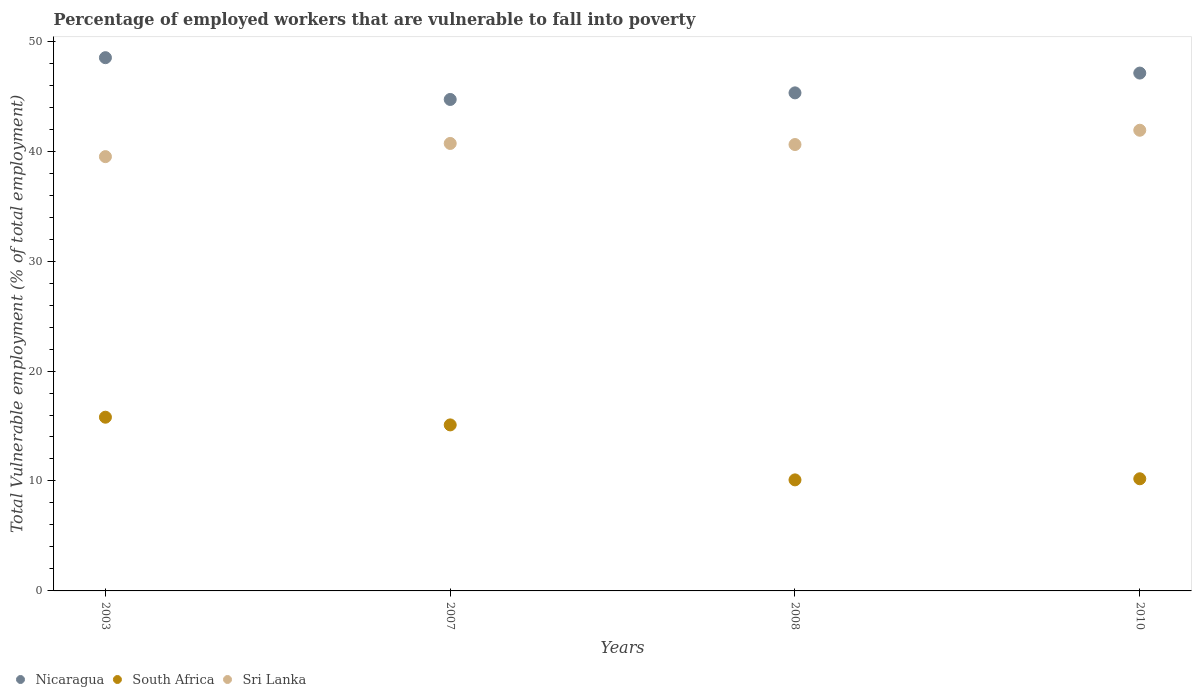How many different coloured dotlines are there?
Ensure brevity in your answer.  3. Is the number of dotlines equal to the number of legend labels?
Your answer should be compact. Yes. What is the percentage of employed workers who are vulnerable to fall into poverty in South Africa in 2007?
Your answer should be very brief. 15.1. Across all years, what is the maximum percentage of employed workers who are vulnerable to fall into poverty in South Africa?
Offer a terse response. 15.8. Across all years, what is the minimum percentage of employed workers who are vulnerable to fall into poverty in South Africa?
Your answer should be very brief. 10.1. What is the total percentage of employed workers who are vulnerable to fall into poverty in Nicaragua in the graph?
Make the answer very short. 185.6. What is the difference between the percentage of employed workers who are vulnerable to fall into poverty in Sri Lanka in 2003 and that in 2010?
Provide a short and direct response. -2.4. What is the difference between the percentage of employed workers who are vulnerable to fall into poverty in South Africa in 2008 and the percentage of employed workers who are vulnerable to fall into poverty in Sri Lanka in 2007?
Keep it short and to the point. -30.6. What is the average percentage of employed workers who are vulnerable to fall into poverty in South Africa per year?
Your answer should be compact. 12.8. In the year 2010, what is the difference between the percentage of employed workers who are vulnerable to fall into poverty in Sri Lanka and percentage of employed workers who are vulnerable to fall into poverty in Nicaragua?
Provide a short and direct response. -5.2. In how many years, is the percentage of employed workers who are vulnerable to fall into poverty in Sri Lanka greater than 4 %?
Offer a very short reply. 4. What is the ratio of the percentage of employed workers who are vulnerable to fall into poverty in Sri Lanka in 2003 to that in 2010?
Offer a very short reply. 0.94. What is the difference between the highest and the second highest percentage of employed workers who are vulnerable to fall into poverty in Nicaragua?
Provide a short and direct response. 1.4. What is the difference between the highest and the lowest percentage of employed workers who are vulnerable to fall into poverty in Nicaragua?
Give a very brief answer. 3.8. In how many years, is the percentage of employed workers who are vulnerable to fall into poverty in South Africa greater than the average percentage of employed workers who are vulnerable to fall into poverty in South Africa taken over all years?
Provide a short and direct response. 2. Is the percentage of employed workers who are vulnerable to fall into poverty in Nicaragua strictly less than the percentage of employed workers who are vulnerable to fall into poverty in Sri Lanka over the years?
Keep it short and to the point. No. How many dotlines are there?
Your answer should be very brief. 3. What is the difference between two consecutive major ticks on the Y-axis?
Keep it short and to the point. 10. Does the graph contain any zero values?
Provide a short and direct response. No. Does the graph contain grids?
Your answer should be compact. No. Where does the legend appear in the graph?
Provide a succinct answer. Bottom left. How many legend labels are there?
Make the answer very short. 3. What is the title of the graph?
Offer a terse response. Percentage of employed workers that are vulnerable to fall into poverty. Does "Middle East & North Africa (all income levels)" appear as one of the legend labels in the graph?
Keep it short and to the point. No. What is the label or title of the X-axis?
Give a very brief answer. Years. What is the label or title of the Y-axis?
Your response must be concise. Total Vulnerable employment (% of total employment). What is the Total Vulnerable employment (% of total employment) in Nicaragua in 2003?
Provide a succinct answer. 48.5. What is the Total Vulnerable employment (% of total employment) in South Africa in 2003?
Provide a succinct answer. 15.8. What is the Total Vulnerable employment (% of total employment) of Sri Lanka in 2003?
Make the answer very short. 39.5. What is the Total Vulnerable employment (% of total employment) of Nicaragua in 2007?
Your answer should be very brief. 44.7. What is the Total Vulnerable employment (% of total employment) of South Africa in 2007?
Ensure brevity in your answer.  15.1. What is the Total Vulnerable employment (% of total employment) of Sri Lanka in 2007?
Provide a short and direct response. 40.7. What is the Total Vulnerable employment (% of total employment) of Nicaragua in 2008?
Give a very brief answer. 45.3. What is the Total Vulnerable employment (% of total employment) in South Africa in 2008?
Provide a short and direct response. 10.1. What is the Total Vulnerable employment (% of total employment) of Sri Lanka in 2008?
Your answer should be compact. 40.6. What is the Total Vulnerable employment (% of total employment) in Nicaragua in 2010?
Your answer should be compact. 47.1. What is the Total Vulnerable employment (% of total employment) in South Africa in 2010?
Give a very brief answer. 10.2. What is the Total Vulnerable employment (% of total employment) of Sri Lanka in 2010?
Offer a terse response. 41.9. Across all years, what is the maximum Total Vulnerable employment (% of total employment) in Nicaragua?
Offer a very short reply. 48.5. Across all years, what is the maximum Total Vulnerable employment (% of total employment) of South Africa?
Your response must be concise. 15.8. Across all years, what is the maximum Total Vulnerable employment (% of total employment) in Sri Lanka?
Your answer should be very brief. 41.9. Across all years, what is the minimum Total Vulnerable employment (% of total employment) in Nicaragua?
Keep it short and to the point. 44.7. Across all years, what is the minimum Total Vulnerable employment (% of total employment) of South Africa?
Make the answer very short. 10.1. Across all years, what is the minimum Total Vulnerable employment (% of total employment) in Sri Lanka?
Provide a succinct answer. 39.5. What is the total Total Vulnerable employment (% of total employment) of Nicaragua in the graph?
Your answer should be very brief. 185.6. What is the total Total Vulnerable employment (% of total employment) in South Africa in the graph?
Give a very brief answer. 51.2. What is the total Total Vulnerable employment (% of total employment) of Sri Lanka in the graph?
Give a very brief answer. 162.7. What is the difference between the Total Vulnerable employment (% of total employment) of Nicaragua in 2003 and that in 2008?
Your answer should be compact. 3.2. What is the difference between the Total Vulnerable employment (% of total employment) of Sri Lanka in 2003 and that in 2008?
Keep it short and to the point. -1.1. What is the difference between the Total Vulnerable employment (% of total employment) in Nicaragua in 2003 and that in 2010?
Ensure brevity in your answer.  1.4. What is the difference between the Total Vulnerable employment (% of total employment) of South Africa in 2003 and that in 2010?
Provide a succinct answer. 5.6. What is the difference between the Total Vulnerable employment (% of total employment) of Sri Lanka in 2003 and that in 2010?
Offer a very short reply. -2.4. What is the difference between the Total Vulnerable employment (% of total employment) of Nicaragua in 2007 and that in 2008?
Offer a terse response. -0.6. What is the difference between the Total Vulnerable employment (% of total employment) of Nicaragua in 2007 and that in 2010?
Your response must be concise. -2.4. What is the difference between the Total Vulnerable employment (% of total employment) of South Africa in 2007 and that in 2010?
Provide a succinct answer. 4.9. What is the difference between the Total Vulnerable employment (% of total employment) in Nicaragua in 2008 and that in 2010?
Provide a succinct answer. -1.8. What is the difference between the Total Vulnerable employment (% of total employment) of South Africa in 2008 and that in 2010?
Your answer should be compact. -0.1. What is the difference between the Total Vulnerable employment (% of total employment) in Sri Lanka in 2008 and that in 2010?
Make the answer very short. -1.3. What is the difference between the Total Vulnerable employment (% of total employment) of Nicaragua in 2003 and the Total Vulnerable employment (% of total employment) of South Africa in 2007?
Provide a succinct answer. 33.4. What is the difference between the Total Vulnerable employment (% of total employment) of South Africa in 2003 and the Total Vulnerable employment (% of total employment) of Sri Lanka in 2007?
Your answer should be compact. -24.9. What is the difference between the Total Vulnerable employment (% of total employment) of Nicaragua in 2003 and the Total Vulnerable employment (% of total employment) of South Africa in 2008?
Keep it short and to the point. 38.4. What is the difference between the Total Vulnerable employment (% of total employment) in Nicaragua in 2003 and the Total Vulnerable employment (% of total employment) in Sri Lanka in 2008?
Ensure brevity in your answer.  7.9. What is the difference between the Total Vulnerable employment (% of total employment) of South Africa in 2003 and the Total Vulnerable employment (% of total employment) of Sri Lanka in 2008?
Your response must be concise. -24.8. What is the difference between the Total Vulnerable employment (% of total employment) in Nicaragua in 2003 and the Total Vulnerable employment (% of total employment) in South Africa in 2010?
Ensure brevity in your answer.  38.3. What is the difference between the Total Vulnerable employment (% of total employment) of South Africa in 2003 and the Total Vulnerable employment (% of total employment) of Sri Lanka in 2010?
Offer a very short reply. -26.1. What is the difference between the Total Vulnerable employment (% of total employment) in Nicaragua in 2007 and the Total Vulnerable employment (% of total employment) in South Africa in 2008?
Provide a succinct answer. 34.6. What is the difference between the Total Vulnerable employment (% of total employment) of South Africa in 2007 and the Total Vulnerable employment (% of total employment) of Sri Lanka in 2008?
Provide a short and direct response. -25.5. What is the difference between the Total Vulnerable employment (% of total employment) of Nicaragua in 2007 and the Total Vulnerable employment (% of total employment) of South Africa in 2010?
Your answer should be very brief. 34.5. What is the difference between the Total Vulnerable employment (% of total employment) in South Africa in 2007 and the Total Vulnerable employment (% of total employment) in Sri Lanka in 2010?
Your answer should be compact. -26.8. What is the difference between the Total Vulnerable employment (% of total employment) of Nicaragua in 2008 and the Total Vulnerable employment (% of total employment) of South Africa in 2010?
Ensure brevity in your answer.  35.1. What is the difference between the Total Vulnerable employment (% of total employment) of South Africa in 2008 and the Total Vulnerable employment (% of total employment) of Sri Lanka in 2010?
Make the answer very short. -31.8. What is the average Total Vulnerable employment (% of total employment) in Nicaragua per year?
Offer a very short reply. 46.4. What is the average Total Vulnerable employment (% of total employment) in Sri Lanka per year?
Offer a terse response. 40.67. In the year 2003, what is the difference between the Total Vulnerable employment (% of total employment) of Nicaragua and Total Vulnerable employment (% of total employment) of South Africa?
Provide a succinct answer. 32.7. In the year 2003, what is the difference between the Total Vulnerable employment (% of total employment) in Nicaragua and Total Vulnerable employment (% of total employment) in Sri Lanka?
Offer a very short reply. 9. In the year 2003, what is the difference between the Total Vulnerable employment (% of total employment) of South Africa and Total Vulnerable employment (% of total employment) of Sri Lanka?
Your response must be concise. -23.7. In the year 2007, what is the difference between the Total Vulnerable employment (% of total employment) of Nicaragua and Total Vulnerable employment (% of total employment) of South Africa?
Your response must be concise. 29.6. In the year 2007, what is the difference between the Total Vulnerable employment (% of total employment) in South Africa and Total Vulnerable employment (% of total employment) in Sri Lanka?
Your answer should be very brief. -25.6. In the year 2008, what is the difference between the Total Vulnerable employment (% of total employment) in Nicaragua and Total Vulnerable employment (% of total employment) in South Africa?
Your answer should be very brief. 35.2. In the year 2008, what is the difference between the Total Vulnerable employment (% of total employment) in Nicaragua and Total Vulnerable employment (% of total employment) in Sri Lanka?
Make the answer very short. 4.7. In the year 2008, what is the difference between the Total Vulnerable employment (% of total employment) of South Africa and Total Vulnerable employment (% of total employment) of Sri Lanka?
Your answer should be compact. -30.5. In the year 2010, what is the difference between the Total Vulnerable employment (% of total employment) of Nicaragua and Total Vulnerable employment (% of total employment) of South Africa?
Make the answer very short. 36.9. In the year 2010, what is the difference between the Total Vulnerable employment (% of total employment) of Nicaragua and Total Vulnerable employment (% of total employment) of Sri Lanka?
Ensure brevity in your answer.  5.2. In the year 2010, what is the difference between the Total Vulnerable employment (% of total employment) in South Africa and Total Vulnerable employment (% of total employment) in Sri Lanka?
Ensure brevity in your answer.  -31.7. What is the ratio of the Total Vulnerable employment (% of total employment) in Nicaragua in 2003 to that in 2007?
Provide a short and direct response. 1.08. What is the ratio of the Total Vulnerable employment (% of total employment) of South Africa in 2003 to that in 2007?
Make the answer very short. 1.05. What is the ratio of the Total Vulnerable employment (% of total employment) of Sri Lanka in 2003 to that in 2007?
Your response must be concise. 0.97. What is the ratio of the Total Vulnerable employment (% of total employment) of Nicaragua in 2003 to that in 2008?
Your answer should be very brief. 1.07. What is the ratio of the Total Vulnerable employment (% of total employment) in South Africa in 2003 to that in 2008?
Keep it short and to the point. 1.56. What is the ratio of the Total Vulnerable employment (% of total employment) of Sri Lanka in 2003 to that in 2008?
Your answer should be very brief. 0.97. What is the ratio of the Total Vulnerable employment (% of total employment) of Nicaragua in 2003 to that in 2010?
Keep it short and to the point. 1.03. What is the ratio of the Total Vulnerable employment (% of total employment) of South Africa in 2003 to that in 2010?
Provide a short and direct response. 1.55. What is the ratio of the Total Vulnerable employment (% of total employment) in Sri Lanka in 2003 to that in 2010?
Provide a succinct answer. 0.94. What is the ratio of the Total Vulnerable employment (% of total employment) of Nicaragua in 2007 to that in 2008?
Ensure brevity in your answer.  0.99. What is the ratio of the Total Vulnerable employment (% of total employment) in South Africa in 2007 to that in 2008?
Make the answer very short. 1.5. What is the ratio of the Total Vulnerable employment (% of total employment) in Sri Lanka in 2007 to that in 2008?
Give a very brief answer. 1. What is the ratio of the Total Vulnerable employment (% of total employment) in Nicaragua in 2007 to that in 2010?
Ensure brevity in your answer.  0.95. What is the ratio of the Total Vulnerable employment (% of total employment) in South Africa in 2007 to that in 2010?
Offer a terse response. 1.48. What is the ratio of the Total Vulnerable employment (% of total employment) in Sri Lanka in 2007 to that in 2010?
Ensure brevity in your answer.  0.97. What is the ratio of the Total Vulnerable employment (% of total employment) in Nicaragua in 2008 to that in 2010?
Give a very brief answer. 0.96. What is the ratio of the Total Vulnerable employment (% of total employment) of South Africa in 2008 to that in 2010?
Your answer should be very brief. 0.99. What is the difference between the highest and the second highest Total Vulnerable employment (% of total employment) of Nicaragua?
Keep it short and to the point. 1.4. What is the difference between the highest and the lowest Total Vulnerable employment (% of total employment) in Nicaragua?
Provide a succinct answer. 3.8. What is the difference between the highest and the lowest Total Vulnerable employment (% of total employment) in South Africa?
Provide a short and direct response. 5.7. 